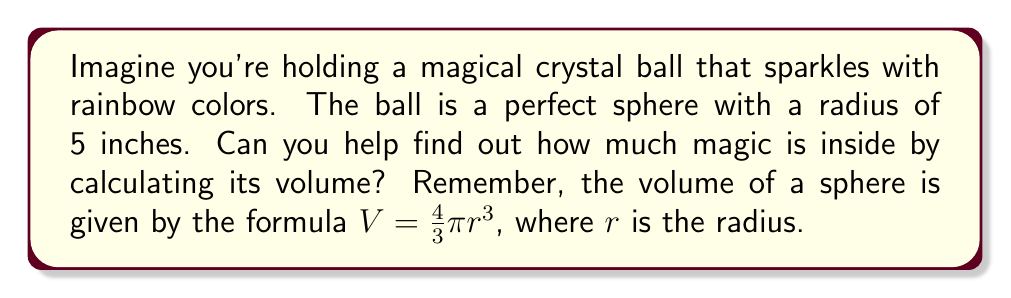Teach me how to tackle this problem. Let's break this down into simple steps:

1. We know the radius of our magical crystal ball is 5 inches.

2. The formula for the volume of a sphere is:
   $$V = \frac{4}{3}\pi r^3$$

3. Let's substitute our radius (5 inches) into the formula:
   $$V = \frac{4}{3}\pi (5)^3$$

4. First, let's calculate $5^3$:
   $$5^3 = 5 \times 5 \times 5 = 125$$

5. Now our equation looks like this:
   $$V = \frac{4}{3}\pi (125)$$

6. Let's multiply $\frac{4}{3}$ by 125:
   $$V = \frac{500}{3}\pi$$

7. We can leave our answer in terms of $\pi$, or we can use 3.14159 as an approximation for $\pi$:
   $$V \approx \frac{500}{3} \times 3.14159 \approx 523.5983$$

So, the volume of our magical crystal ball is approximately 523.5983 cubic inches.

[asy]
import geometry;

size(100);
draw(circle((0,0),5));
dot((0,0));
draw((0,0)--(5,0),Arrow);
label("5 in",(-1,-2.5),NE);
label("r",(2.5,0.5),N);
[/asy]
Answer: The volume of the magical crystal ball is $\frac{500}{3}\pi$ cubic inches, or approximately 523.5983 cubic inches. 